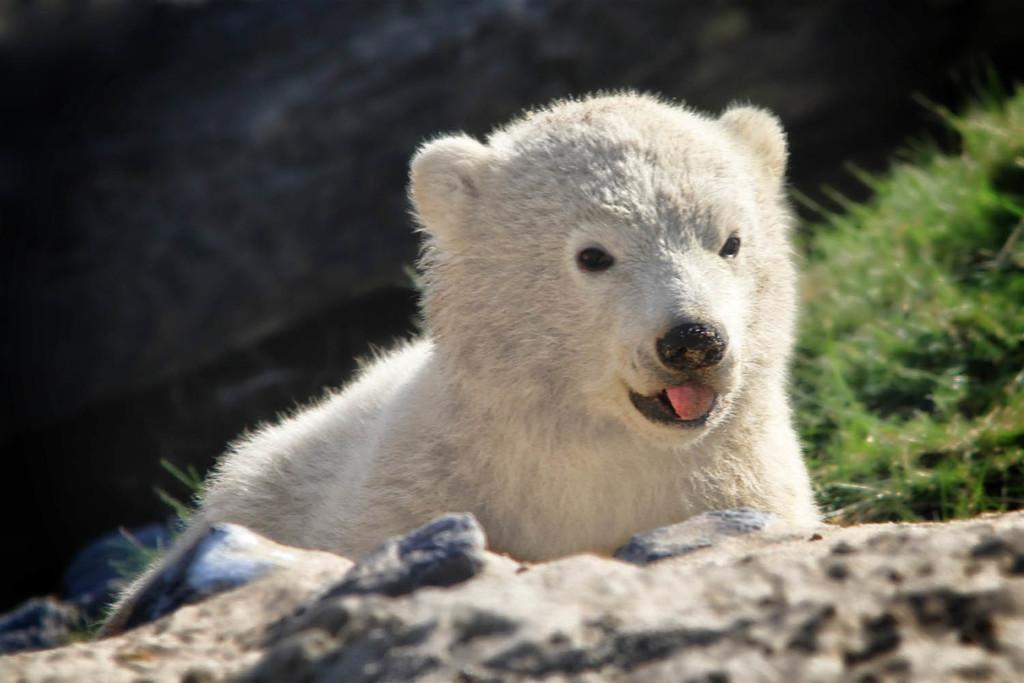What animal is the main subject of the image? There is a polar bear in the image. What type of terrain is visible at the bottom of the image? There are rocks at the bottom of the image. What type of vegetation is on the right side of the image? There is grass on the right side of the image. How would you describe the background of the image? The background of the image is blurred. What level of reading proficiency does the polar bear have in the image? There is no indication of reading proficiency in the image, as polar bears do not read. 